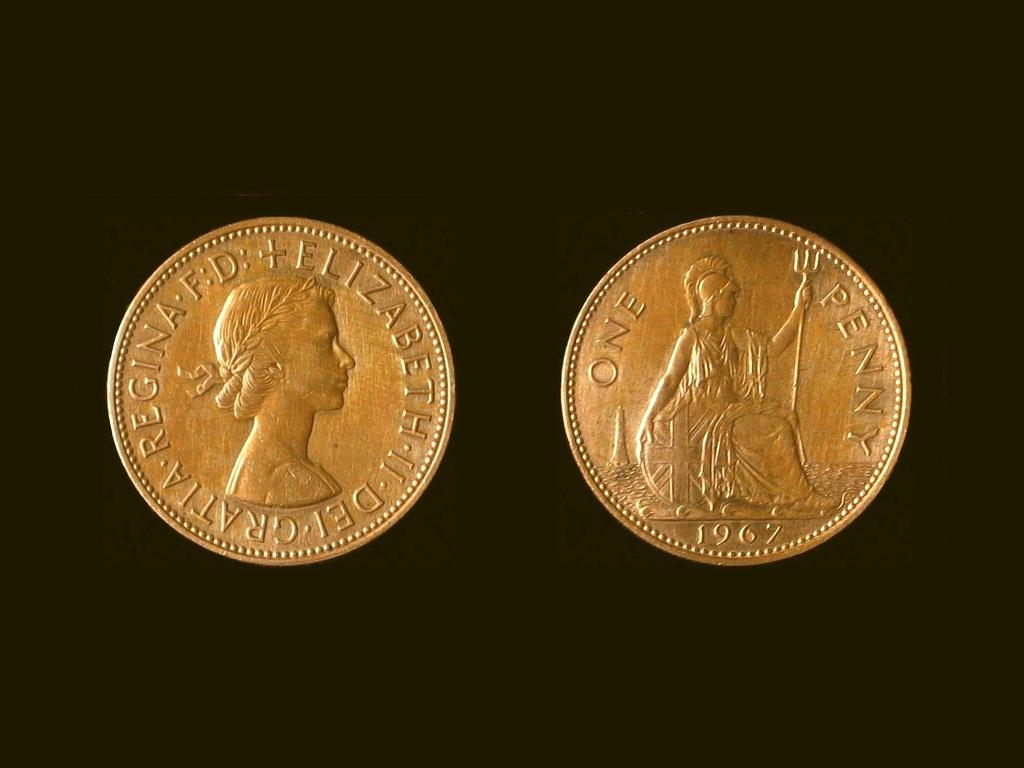<image>
Offer a succinct explanation of the picture presented. Two gold coins one is a penny from 1967. 